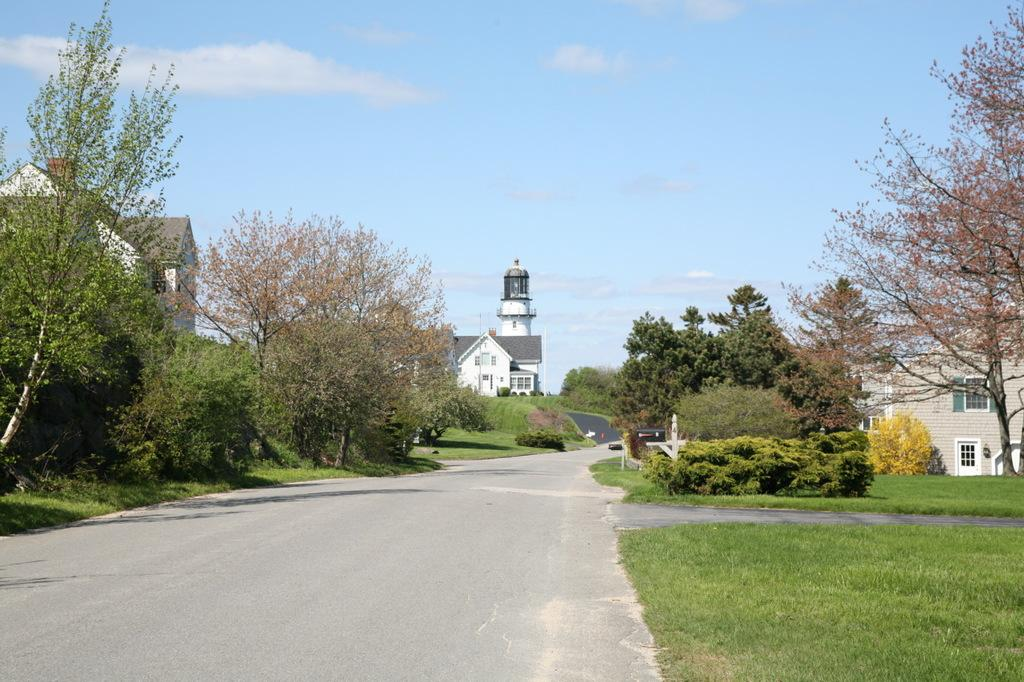What type of structures can be seen in the image? There are buildings with windows in the image. What is the tall, cylindrical structure in the image? There is a lighthouse in the image. What type of vegetation is present in the image? There are trees, plants, and grass in the image. What can be used for walking or traveling in the image? There is a pathway in the image. What is the condition of the sky in the image? The sky is visible in the image and appears cloudy. How many eyes can be seen on the lighthouse in the image? There are no eyes present on the lighthouse in the image; it is an inanimate object. What is the size of the eggs in the image? There are no eggs present in the image. 